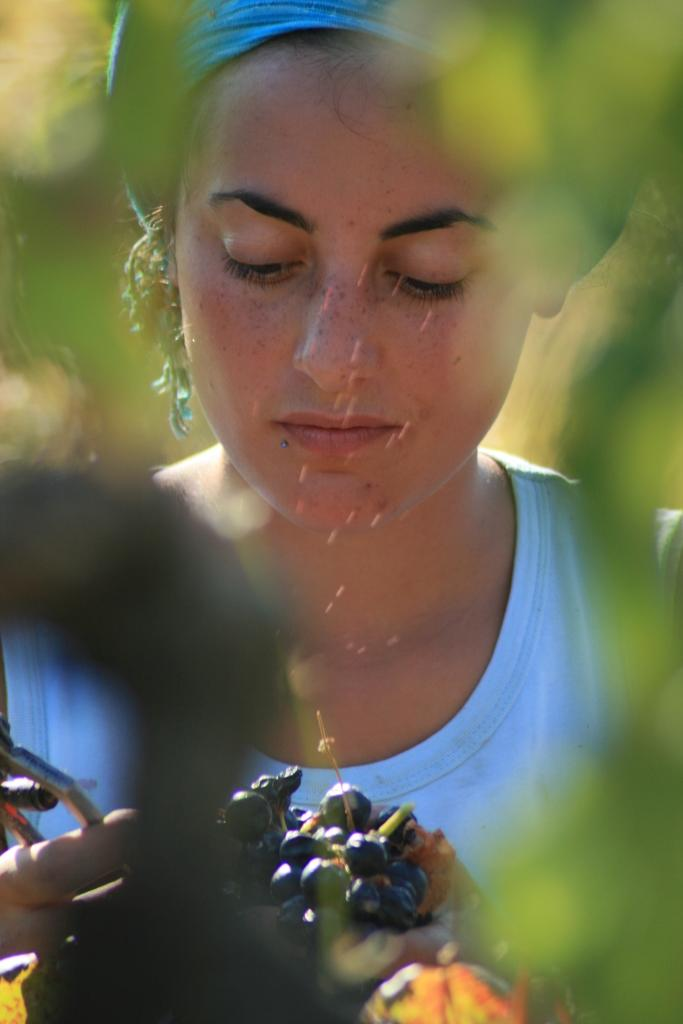Who is present in the image? There is a woman in the image. What is the woman wearing? The woman is wearing a blue dress. What else can be seen in the image besides the woman? There are fruits and plants in the image. What is the governor doing in the image? There is no governor present in the image. Is the woman using a comb in the image? There is no comb visible in the image. 